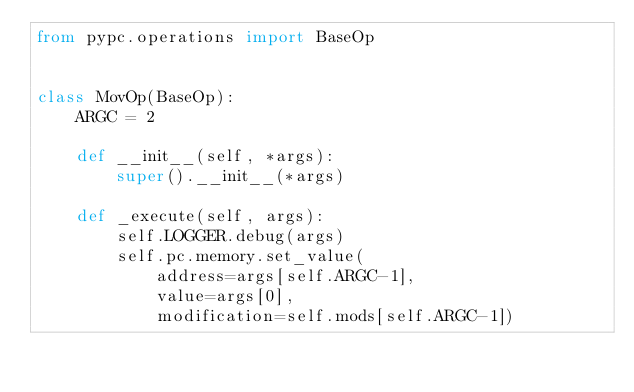Convert code to text. <code><loc_0><loc_0><loc_500><loc_500><_Python_>from pypc.operations import BaseOp


class MovOp(BaseOp):
    ARGC = 2

    def __init__(self, *args):
        super().__init__(*args)

    def _execute(self, args):
        self.LOGGER.debug(args)
        self.pc.memory.set_value(
            address=args[self.ARGC-1],
            value=args[0],
            modification=self.mods[self.ARGC-1])
</code> 